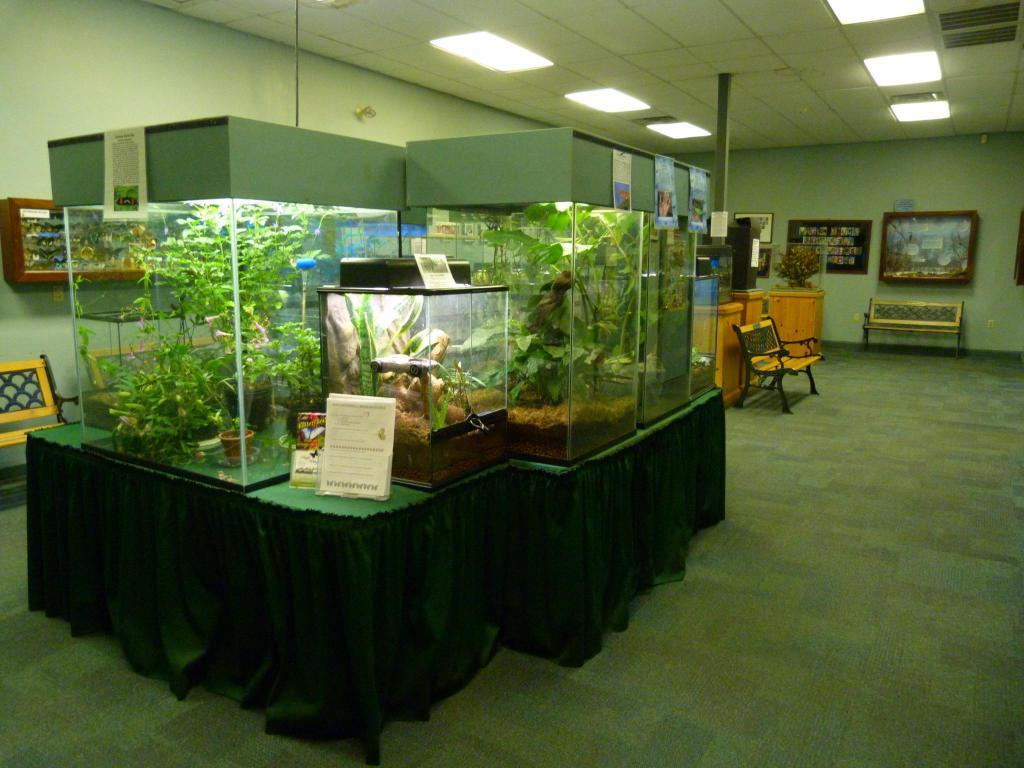What type of seating is available in the image? There are benches in the image. What is unique about the plants in the image? The plants are in glass objects in the image. What type of lighting is present in the image? There are lights on the ceiling in the image. What is attached to the walls in the image? There are objects attached to the walls in the image. Can you describe any other objects visible in the image? There are other objects visible in the image, but their specific details are not mentioned in the provided facts. What type of notebook is being used by the organization in the image? There is no notebook or organization present in the image. What type of machine is being used by the people in the image? There is no machine or people present in the image. 